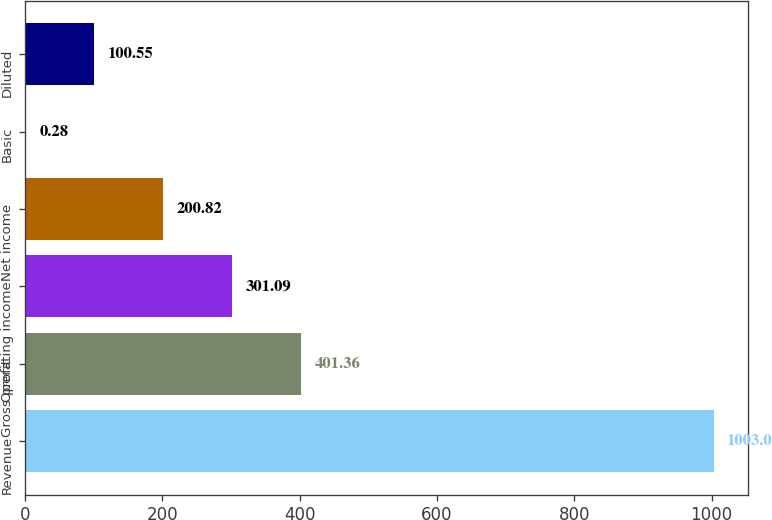<chart> <loc_0><loc_0><loc_500><loc_500><bar_chart><fcel>Revenue<fcel>Gross profit<fcel>Operating income<fcel>Net income<fcel>Basic<fcel>Diluted<nl><fcel>1003<fcel>401.36<fcel>301.09<fcel>200.82<fcel>0.28<fcel>100.55<nl></chart> 